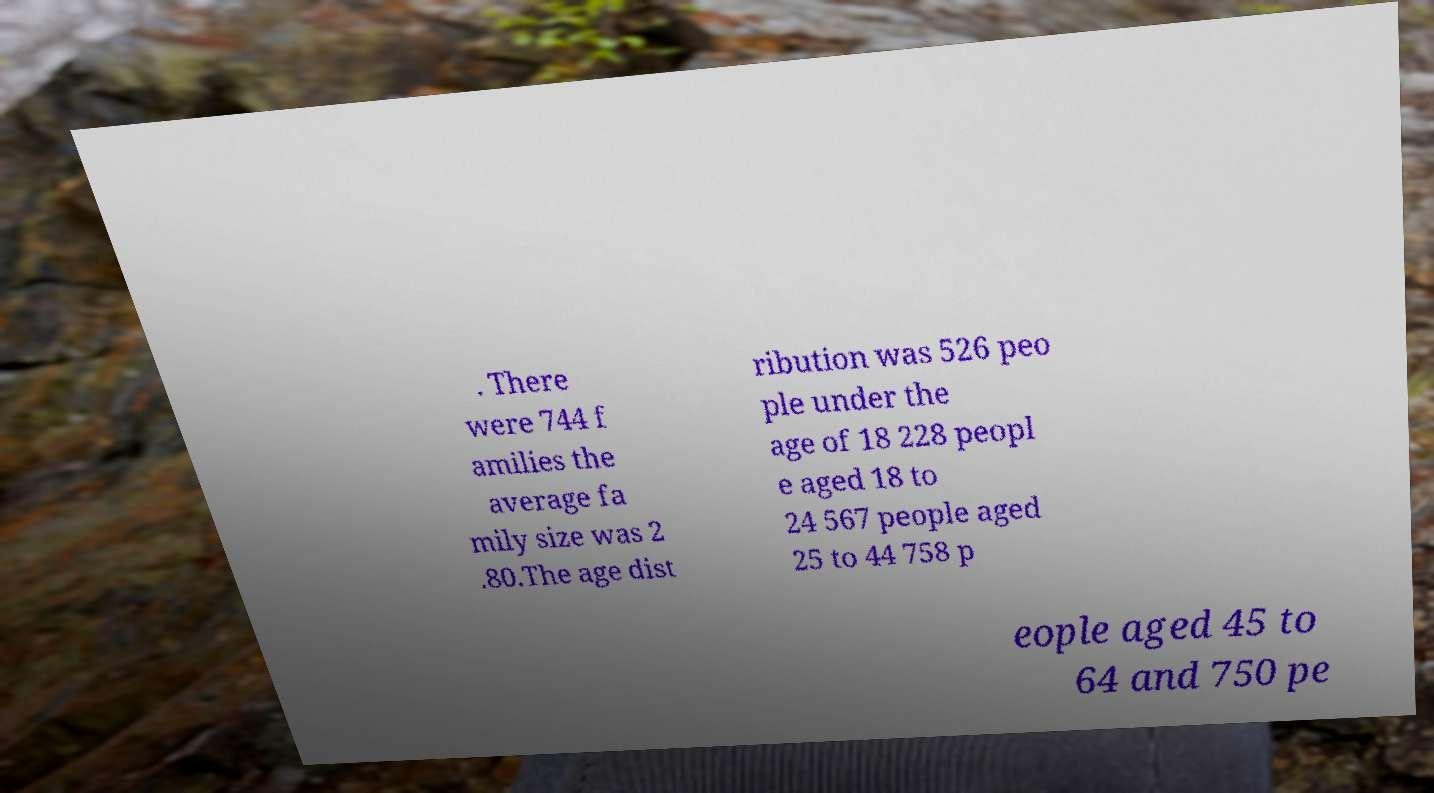Can you read and provide the text displayed in the image?This photo seems to have some interesting text. Can you extract and type it out for me? . There were 744 f amilies the average fa mily size was 2 .80.The age dist ribution was 526 peo ple under the age of 18 228 peopl e aged 18 to 24 567 people aged 25 to 44 758 p eople aged 45 to 64 and 750 pe 